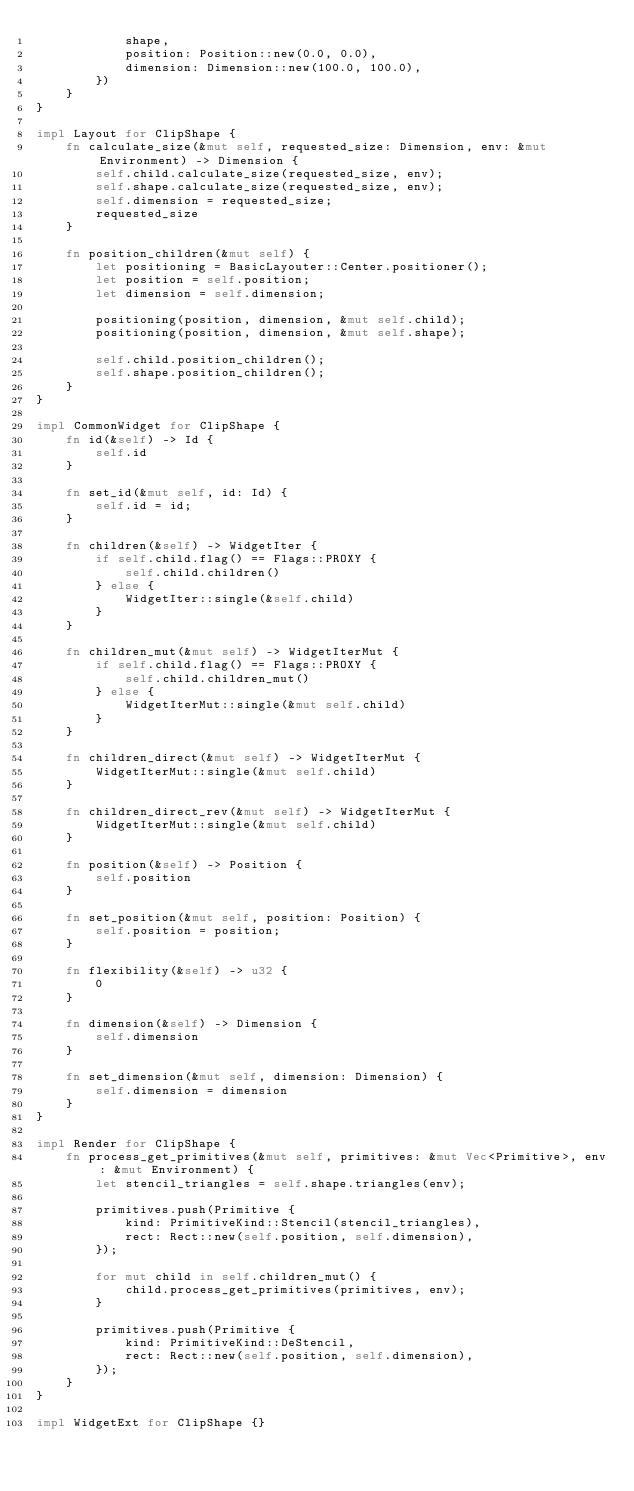<code> <loc_0><loc_0><loc_500><loc_500><_Rust_>            shape,
            position: Position::new(0.0, 0.0),
            dimension: Dimension::new(100.0, 100.0),
        })
    }
}

impl Layout for ClipShape {
    fn calculate_size(&mut self, requested_size: Dimension, env: &mut Environment) -> Dimension {
        self.child.calculate_size(requested_size, env);
        self.shape.calculate_size(requested_size, env);
        self.dimension = requested_size;
        requested_size
    }

    fn position_children(&mut self) {
        let positioning = BasicLayouter::Center.positioner();
        let position = self.position;
        let dimension = self.dimension;

        positioning(position, dimension, &mut self.child);
        positioning(position, dimension, &mut self.shape);

        self.child.position_children();
        self.shape.position_children();
    }
}

impl CommonWidget for ClipShape {
    fn id(&self) -> Id {
        self.id
    }

    fn set_id(&mut self, id: Id) {
        self.id = id;
    }

    fn children(&self) -> WidgetIter {
        if self.child.flag() == Flags::PROXY {
            self.child.children()
        } else {
            WidgetIter::single(&self.child)
        }
    }

    fn children_mut(&mut self) -> WidgetIterMut {
        if self.child.flag() == Flags::PROXY {
            self.child.children_mut()
        } else {
            WidgetIterMut::single(&mut self.child)
        }
    }

    fn children_direct(&mut self) -> WidgetIterMut {
        WidgetIterMut::single(&mut self.child)
    }

    fn children_direct_rev(&mut self) -> WidgetIterMut {
        WidgetIterMut::single(&mut self.child)
    }

    fn position(&self) -> Position {
        self.position
    }

    fn set_position(&mut self, position: Position) {
        self.position = position;
    }

    fn flexibility(&self) -> u32 {
        0
    }

    fn dimension(&self) -> Dimension {
        self.dimension
    }

    fn set_dimension(&mut self, dimension: Dimension) {
        self.dimension = dimension
    }
}

impl Render for ClipShape {
    fn process_get_primitives(&mut self, primitives: &mut Vec<Primitive>, env: &mut Environment) {
        let stencil_triangles = self.shape.triangles(env);

        primitives.push(Primitive {
            kind: PrimitiveKind::Stencil(stencil_triangles),
            rect: Rect::new(self.position, self.dimension),
        });

        for mut child in self.children_mut() {
            child.process_get_primitives(primitives, env);
        }

        primitives.push(Primitive {
            kind: PrimitiveKind::DeStencil,
            rect: Rect::new(self.position, self.dimension),
        });
    }
}

impl WidgetExt for ClipShape {}
</code> 